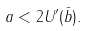Convert formula to latex. <formula><loc_0><loc_0><loc_500><loc_500>a < 2 U ^ { \prime } ( \bar { b } ) .</formula> 